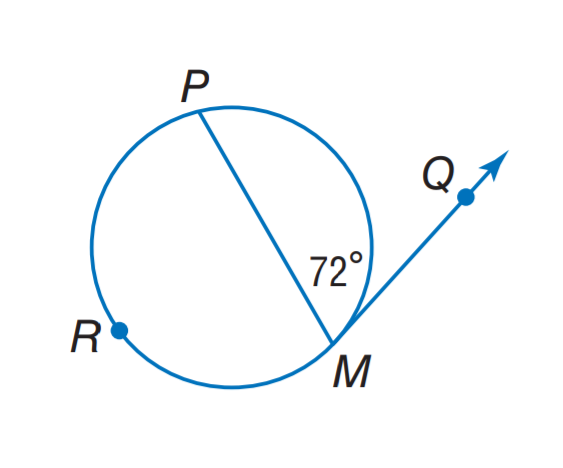Question: Find m \widehat P M.
Choices:
A. 36
B. 72
C. 136
D. 144
Answer with the letter. Answer: D 